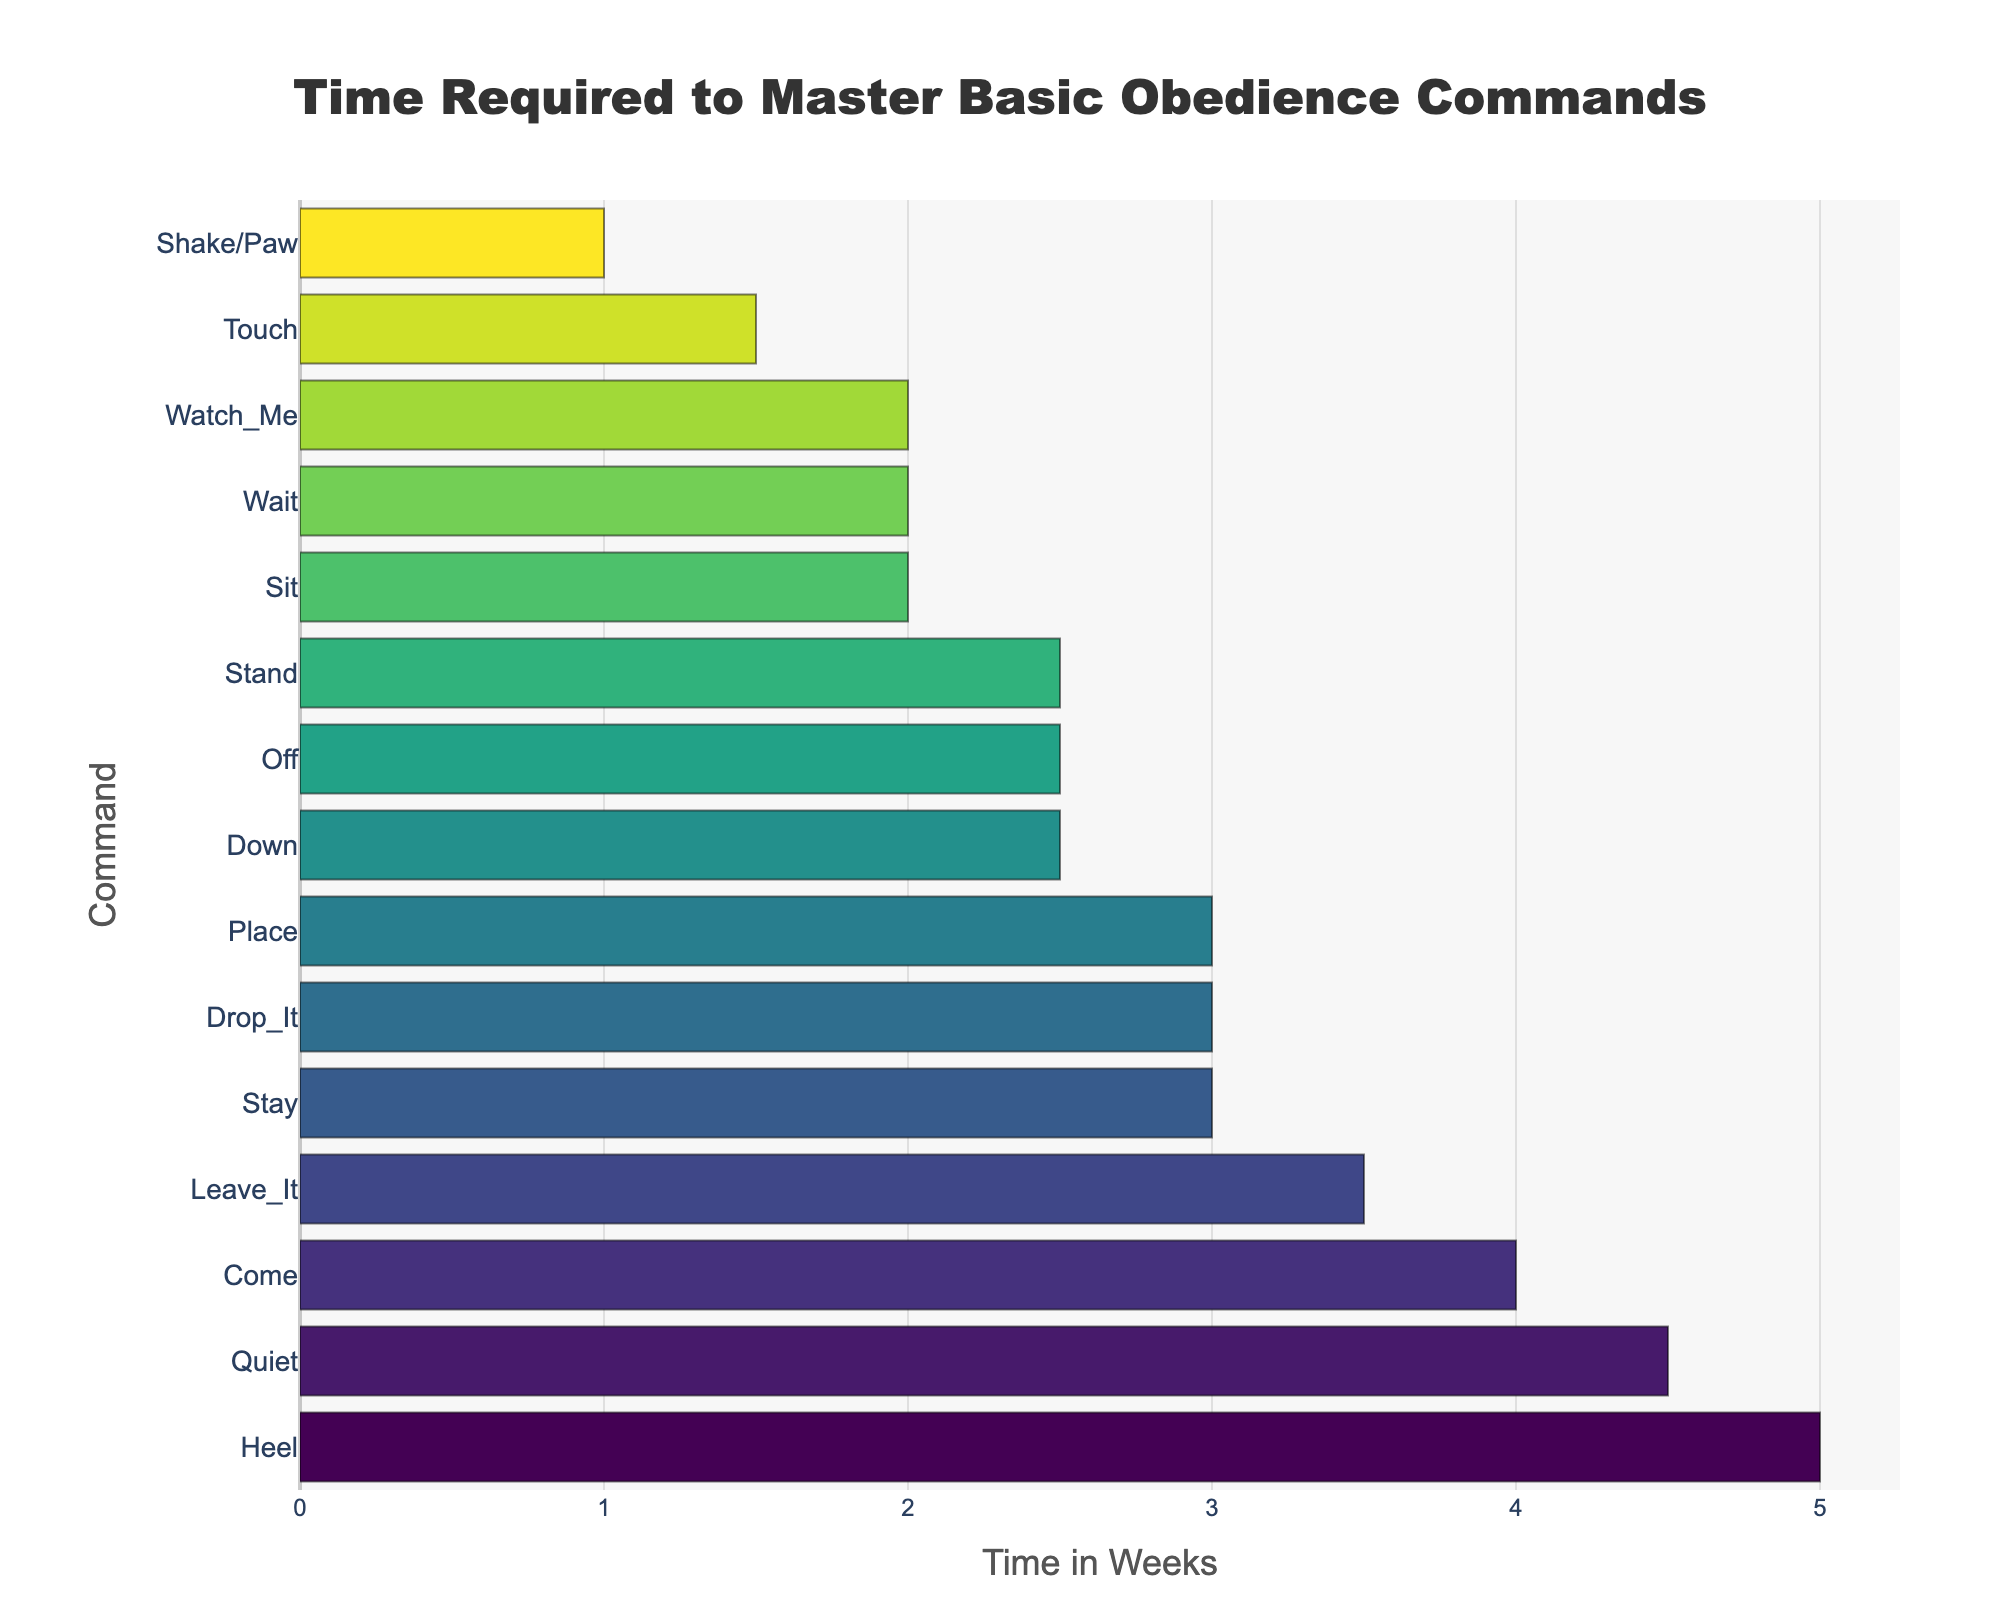Which command takes the longest time to master? Looking at the bar chart, identify the bar with the greatest length on the x-axis. The longest time corresponds to "Heel", which takes 5 weeks.
Answer: Heel Which commands take 2.5 weeks to master? Find the positions where the bars align with the 2.5-week mark on the x-axis. These commands are "Down", "Off", and "Stand".
Answer: Down, Off, Stand What is the difference in time required to master "Sit" and "Quiet"? "Sit" takes 2 weeks, and "Quiet" takes 4.5 weeks. The difference is 4.5 - 2 = 2.5 weeks.
Answer: 2.5 weeks How many commands take 3 weeks or more to master? Count the number of bars that align at 3 weeks or above on the x-axis. There are six commands: "Quiet", "Heel", "Come", "Leave_It", "Stay", and "Drop_It".
Answer: 6 commands Which command takes the least time to master? Identify the command with the shortest bar on the x-axis. The shortest time corresponds to "Shake/Paw", which takes 1 week.
Answer: Shake/Paw What is the average time required to master "Sit", "Wait", and "Quiet"? Sum the times: 2 (Sit) + 2 (Wait) + 4.5 (Quiet) = 8.5 weeks. Divide by the number of commands: 8.5/3 = 2.83 weeks.
Answer: 2.83 weeks Are there more commands that take less than 3 weeks or more than 3 weeks to master? Count the commands less than 3 weeks: "Sit", "Down", "Wait", "Off", "Stand", "Watch_Me", "Touch", "Shake/Paw". Count the commands 3 weeks or more: "Quiet", "Heel", "Come", "Leave_It", "Stay", "Drop_It", "Place". There are 8 commands taking less than 3 weeks and 7 taking 3 weeks or more.
Answer: Less than 3 weeks What is the sum of the times required to master "Come" and "Place"? Add the times: 4 (Come) + 3 (Place) = 7 weeks.
Answer: 7 weeks How does the time to master "Down" compare to "Off"? Both "Down" and "Off" take 2.5 weeks to master, so they are equal in this regard.
Answer: Equal What is the median time required to master all the commands? List the times in ascending order: 1, 1.5, 2, 2, 2.5, 2.5, 2.5, 3, 3, 3.5, 4, 4.5, 5. There are 15 values, so the median is the middle one: the 8th value in the ordered list is 2.5 weeks.
Answer: 2.5 weeks 